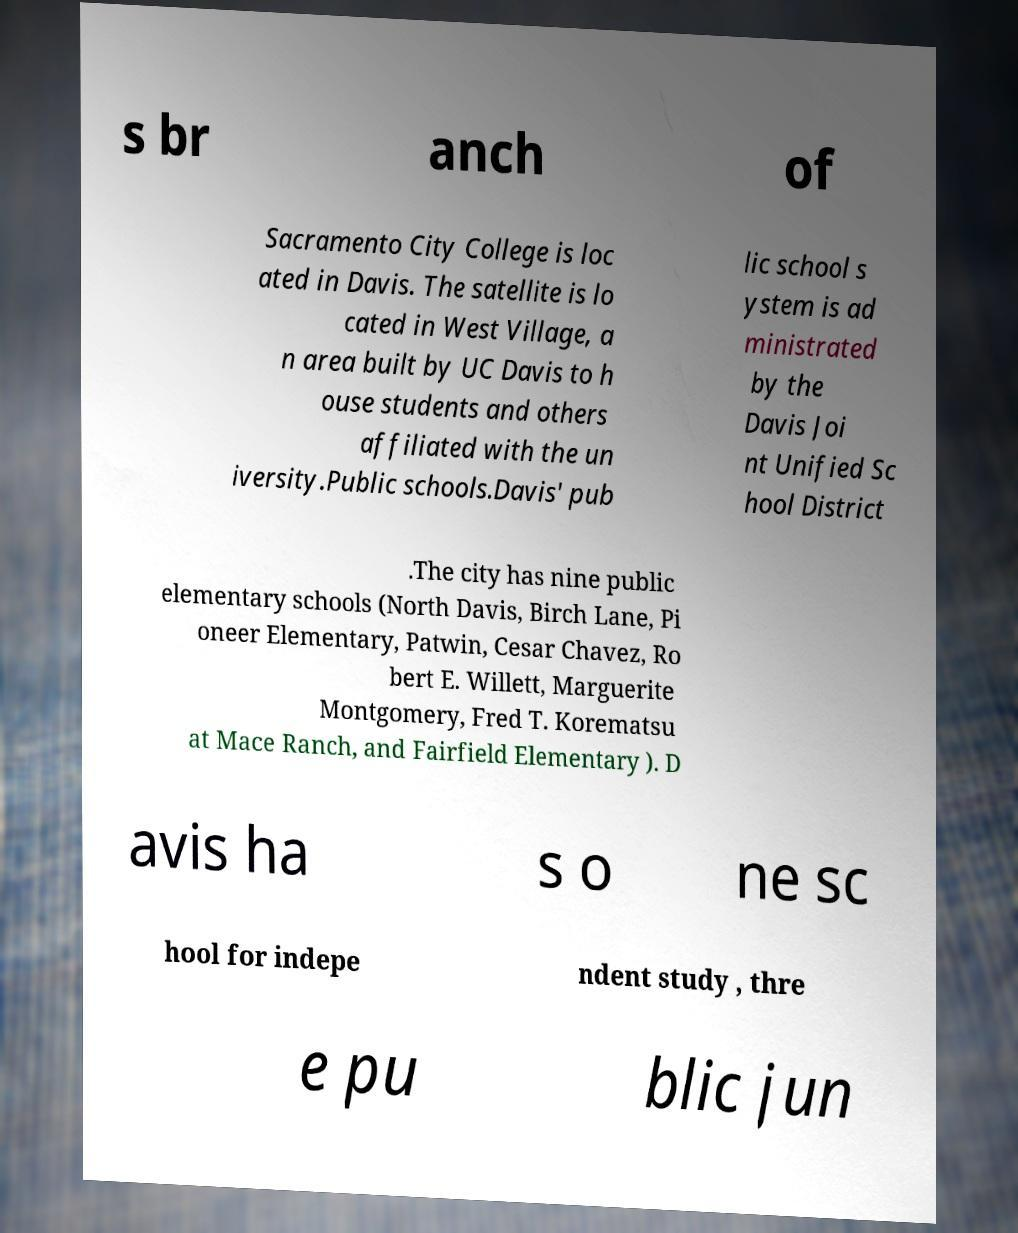I need the written content from this picture converted into text. Can you do that? s br anch of Sacramento City College is loc ated in Davis. The satellite is lo cated in West Village, a n area built by UC Davis to h ouse students and others affiliated with the un iversity.Public schools.Davis' pub lic school s ystem is ad ministrated by the Davis Joi nt Unified Sc hool District .The city has nine public elementary schools (North Davis, Birch Lane, Pi oneer Elementary, Patwin, Cesar Chavez, Ro bert E. Willett, Marguerite Montgomery, Fred T. Korematsu at Mace Ranch, and Fairfield Elementary ). D avis ha s o ne sc hool for indepe ndent study , thre e pu blic jun 